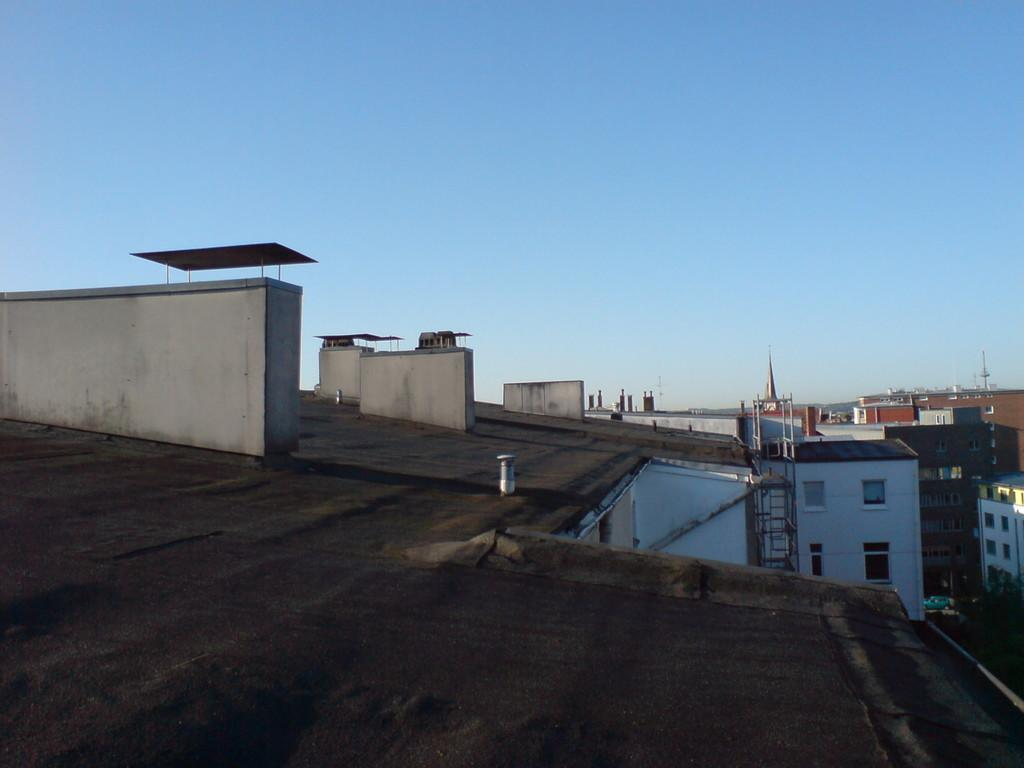Where was the image taken? The image was clicked outside. What can be seen in the foreground of the image? There are buildings and metal rods in the foreground of the image. What part of the buildings is visible in the foreground? The windows of the buildings are visible in the foreground of the image. What can be seen in the background of the image? The sky is visible in the background of the image. How many spiders are crawling on the carpenter's toolbox in the image? There is no carpenter or toolbox present in the image, and therefore no spiders can be observed. 